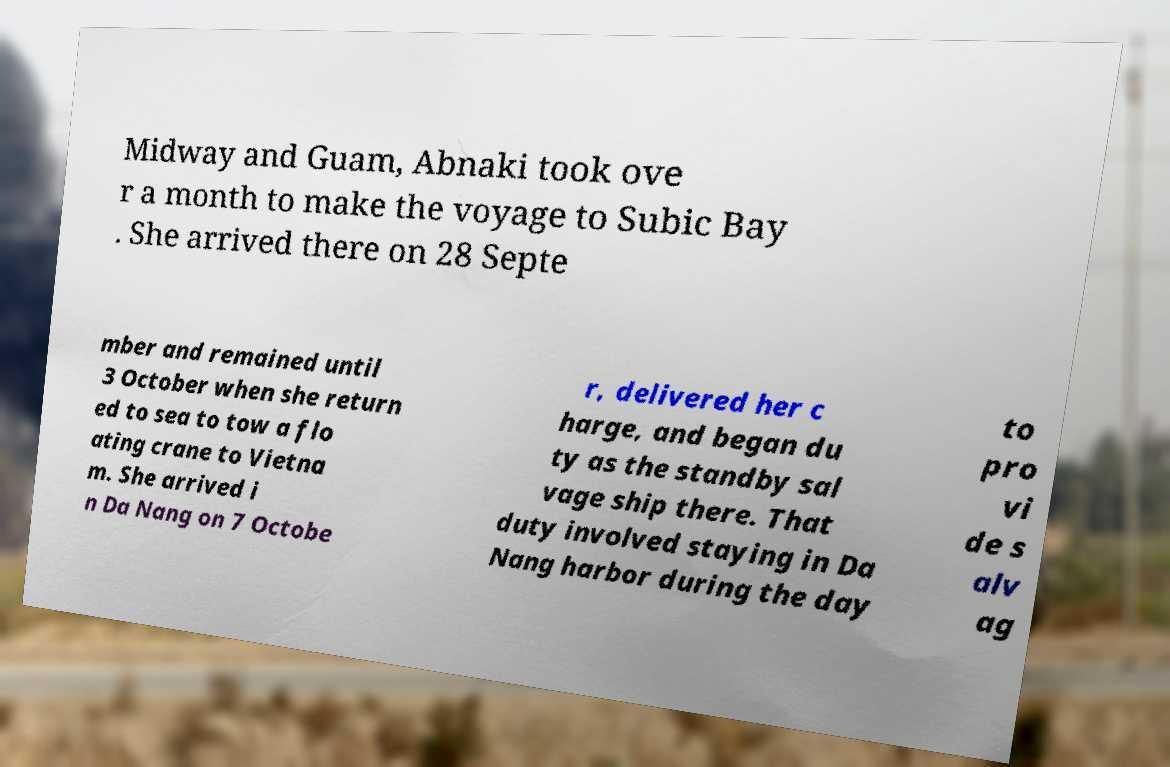Please read and relay the text visible in this image. What does it say? Midway and Guam, Abnaki took ove r a month to make the voyage to Subic Bay . She arrived there on 28 Septe mber and remained until 3 October when she return ed to sea to tow a flo ating crane to Vietna m. She arrived i n Da Nang on 7 Octobe r, delivered her c harge, and began du ty as the standby sal vage ship there. That duty involved staying in Da Nang harbor during the day to pro vi de s alv ag 